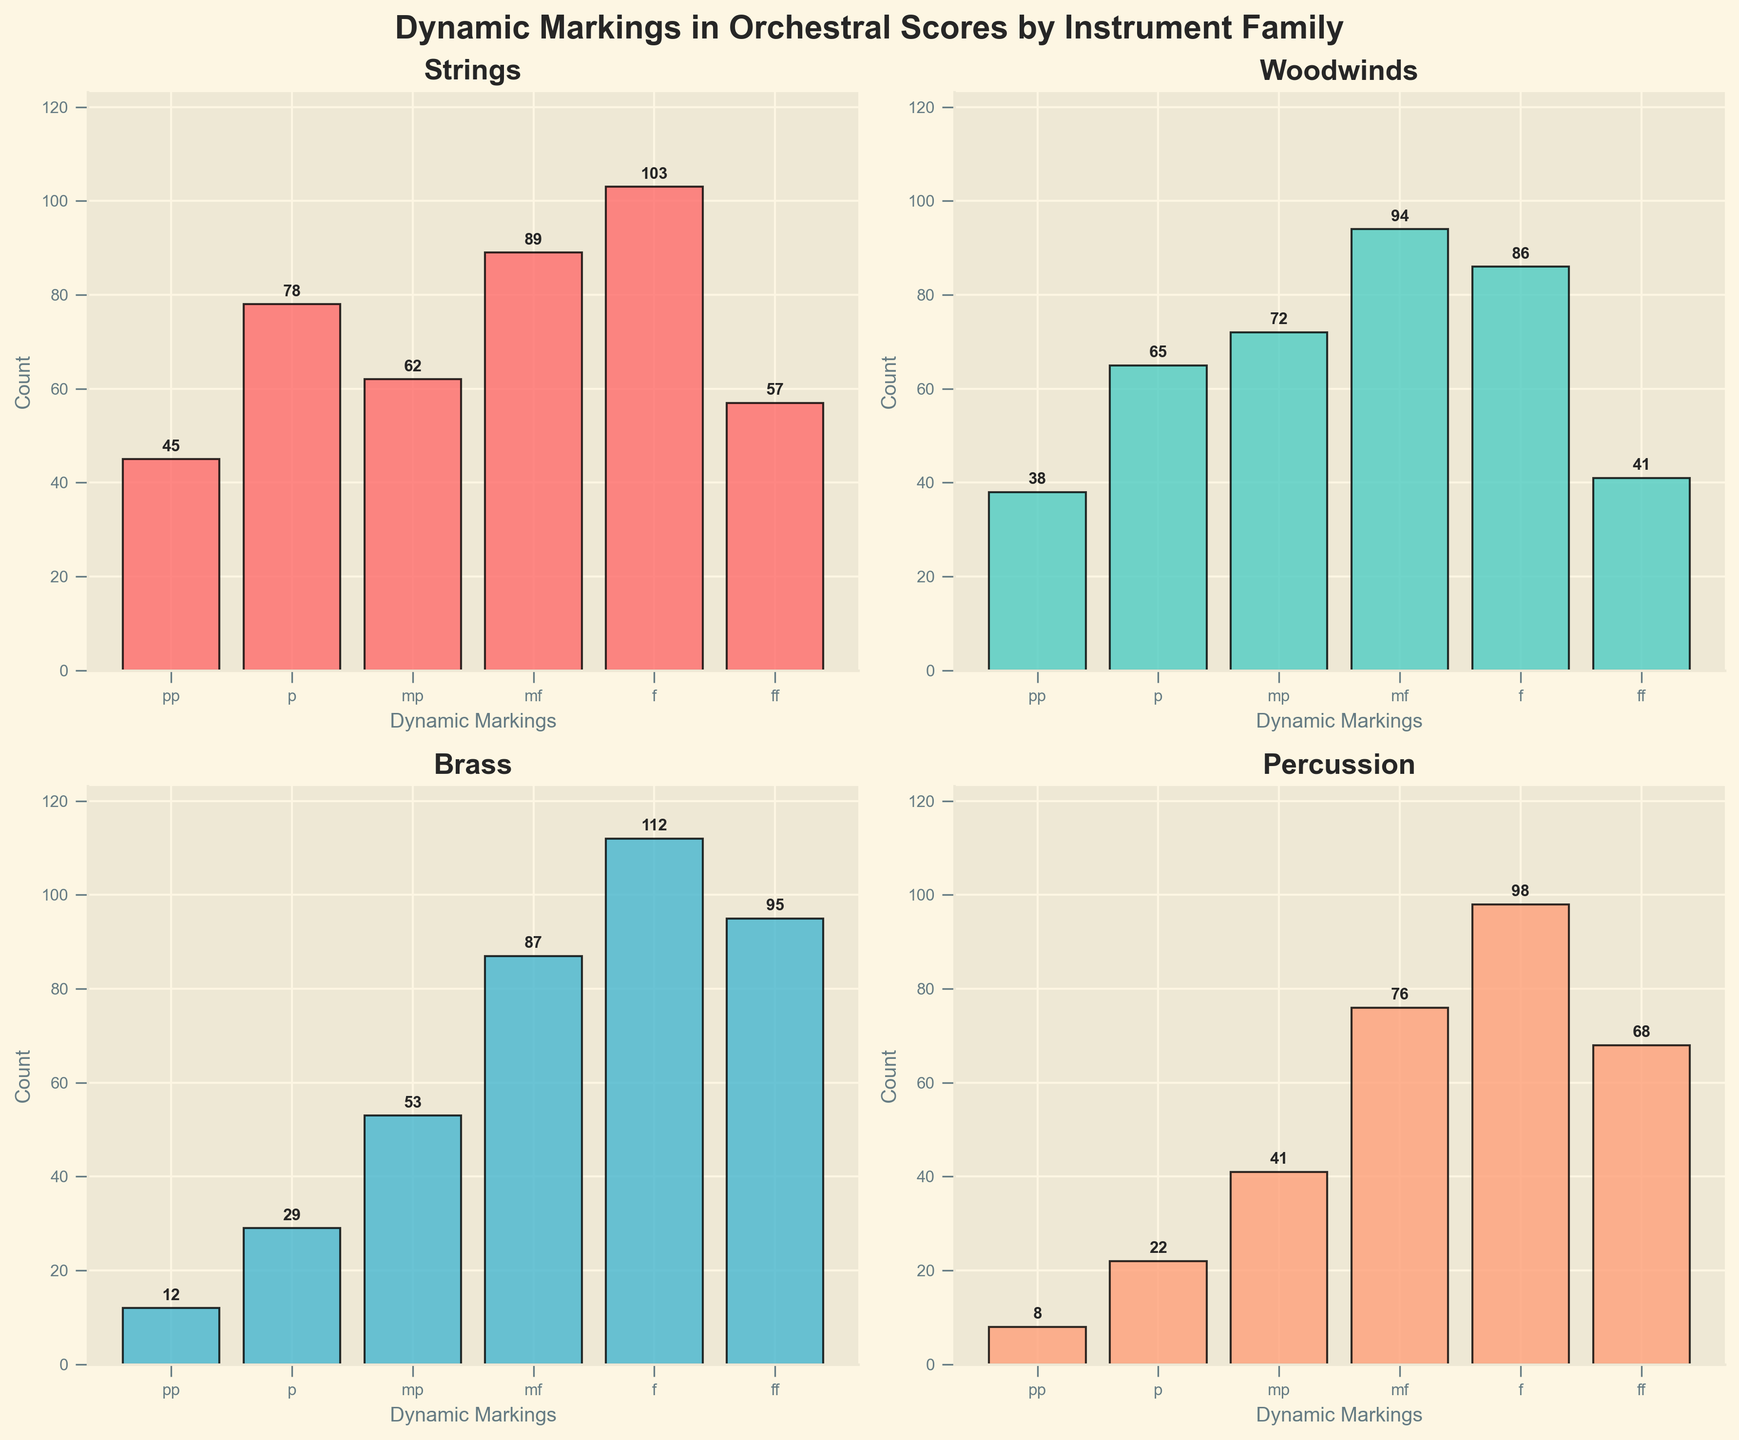What is the title of the entire figure? The title is displayed at the top of the figure above all the subplots. It states the main subject being visualized.
Answer: Dynamic Markings in Orchestral Scores by Instrument Family Which instrument family has the highest count for the 'ff' dynamic marking? Look at each subplot and compare the 'ff' bars. The highest bar for 'ff' dynamic marking is found in the Brass subplot.
Answer: Brass How many more occurrences of 'f' are there in the Strings family compared to the Percussion family? Look at the bars for 'f' in both the Strings and Percussion subplots. The counts are 103 (Strings) and 98 (Percussion). Subtract 98 from 103.
Answer: 5 Which dynamic marking shows the least variance among instrument families? Look at the height of each bar for the dynamic markings across all subplots. The one with the least variation in bar heights across subplots is 'mf'.
Answer: mf What is the total count of 'pp' occurrences across all instrument families? Add up the 'pp' counts from all the subplots: 45 (Strings) + 38 (Woodwinds) + 12 (Brass) + 8 (Percussion).
Answer: 103 Which instrument family has the most consistent (least diverse) counts across all dynamic markings? Compare the range of counts (highest minus lowest) within each subplot. Woodwinds have the closest range among all dynamics.
Answer: Woodwinds By how much does the total 'mf' count exceed the total 'mp' count across all instrument families? Add up the counts for 'mf' and 'mp' dynamics across all subplots. For 'mf': 89 (Strings) + 94 (Woodwinds) + 87 (Brass) + 76 (Percussion) = 346. For 'mp': 62 (Strings) + 72 (Woodwinds) + 53 (Brass) + 41 (Percussion) = 228. Subtract 228 from 346.
Answer: 118 Which dynamic marking is most common overall across all instrument families? Sum the counts for each dynamic marking across all subplots. The dynamic with the highest total is most common.
Answer: f What is the average count of 'p' occurrences across the instrument families? Add up the 'p' counts from all the subplots and divide by the number of instrument families. (78 + 65 + 29 + 22) / 4 = 194 / 4.
Answer: 48.5 Which instrument family shows the greatest difference between the 'pp' and 'ff' dynamic markings? Look at the difference between the 'pp' and 'ff' counts in each subplot. The greatest difference is noted in the Brass family, with 83 (95 - 12).
Answer: Brass 